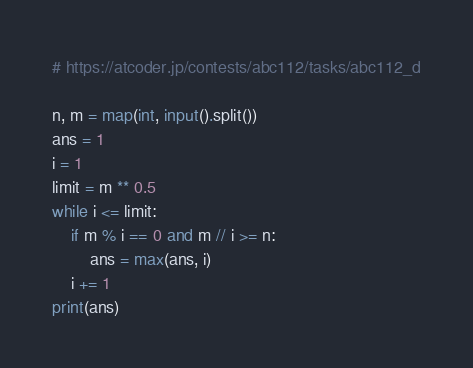<code> <loc_0><loc_0><loc_500><loc_500><_Python_># https://atcoder.jp/contests/abc112/tasks/abc112_d

n, m = map(int, input().split())
ans = 1
i = 1
limit = m ** 0.5
while i <= limit:
    if m % i == 0 and m // i >= n:
        ans = max(ans, i)
    i += 1
print(ans)
</code> 